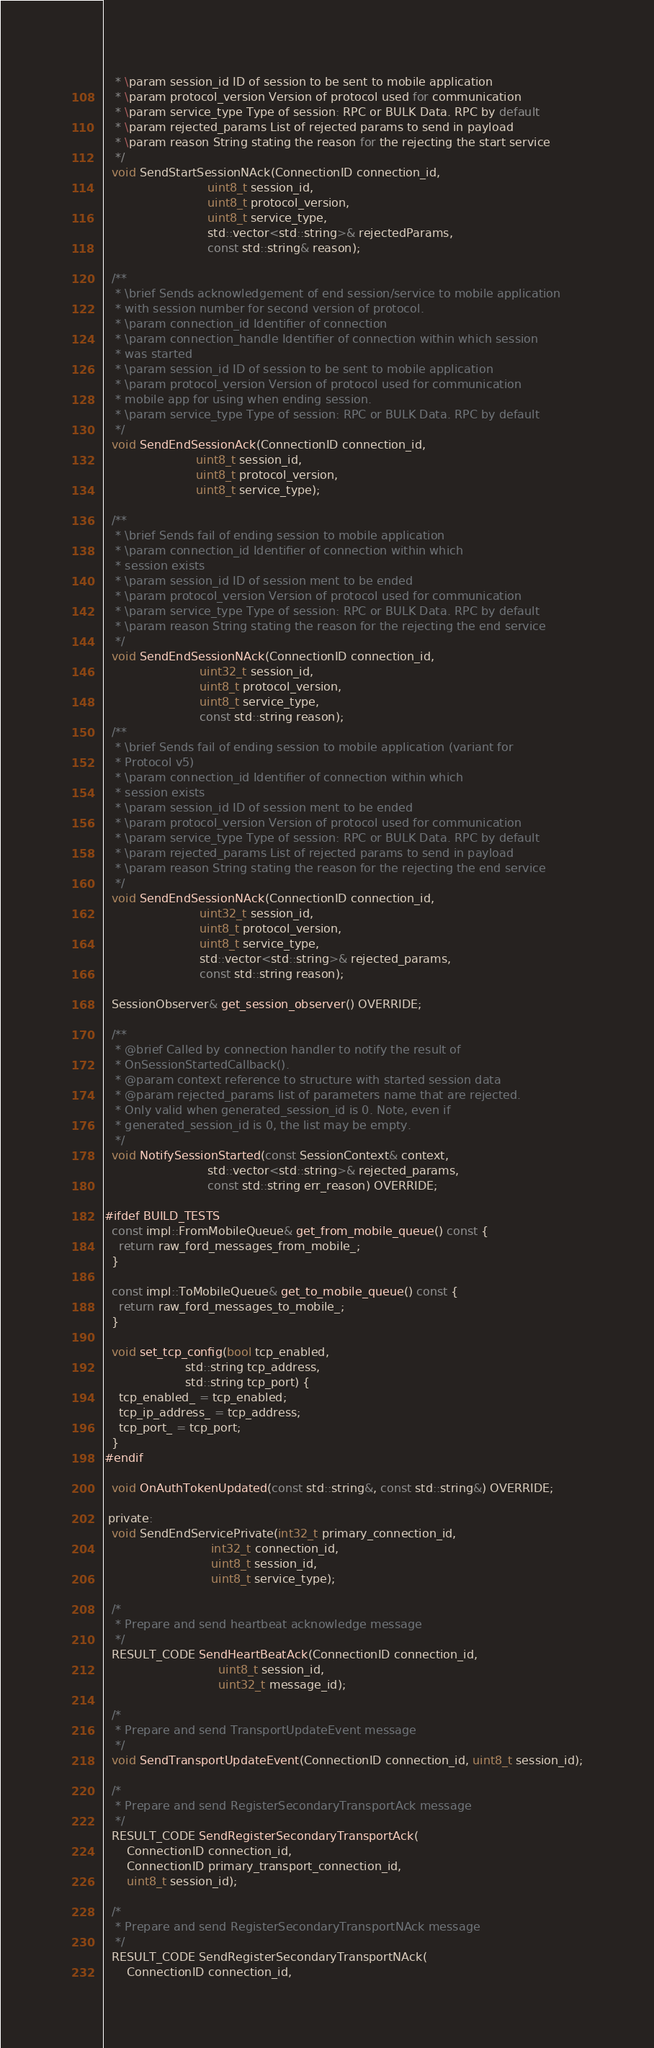<code> <loc_0><loc_0><loc_500><loc_500><_C_>   * \param session_id ID of session to be sent to mobile application
   * \param protocol_version Version of protocol used for communication
   * \param service_type Type of session: RPC or BULK Data. RPC by default
   * \param rejected_params List of rejected params to send in payload
   * \param reason String stating the reason for the rejecting the start service
   */
  void SendStartSessionNAck(ConnectionID connection_id,
                            uint8_t session_id,
                            uint8_t protocol_version,
                            uint8_t service_type,
                            std::vector<std::string>& rejectedParams,
                            const std::string& reason);

  /**
   * \brief Sends acknowledgement of end session/service to mobile application
   * with session number for second version of protocol.
   * \param connection_id Identifier of connection
   * \param connection_handle Identifier of connection within which session
   * was started
   * \param session_id ID of session to be sent to mobile application
   * \param protocol_version Version of protocol used for communication
   * mobile app for using when ending session.
   * \param service_type Type of session: RPC or BULK Data. RPC by default
   */
  void SendEndSessionAck(ConnectionID connection_id,
                         uint8_t session_id,
                         uint8_t protocol_version,
                         uint8_t service_type);

  /**
   * \brief Sends fail of ending session to mobile application
   * \param connection_id Identifier of connection within which
   * session exists
   * \param session_id ID of session ment to be ended
   * \param protocol_version Version of protocol used for communication
   * \param service_type Type of session: RPC or BULK Data. RPC by default
   * \param reason String stating the reason for the rejecting the end service
   */
  void SendEndSessionNAck(ConnectionID connection_id,
                          uint32_t session_id,
                          uint8_t protocol_version,
                          uint8_t service_type,
                          const std::string reason);
  /**
   * \brief Sends fail of ending session to mobile application (variant for
   * Protocol v5)
   * \param connection_id Identifier of connection within which
   * session exists
   * \param session_id ID of session ment to be ended
   * \param protocol_version Version of protocol used for communication
   * \param service_type Type of session: RPC or BULK Data. RPC by default
   * \param rejected_params List of rejected params to send in payload
   * \param reason String stating the reason for the rejecting the end service
   */
  void SendEndSessionNAck(ConnectionID connection_id,
                          uint32_t session_id,
                          uint8_t protocol_version,
                          uint8_t service_type,
                          std::vector<std::string>& rejected_params,
                          const std::string reason);

  SessionObserver& get_session_observer() OVERRIDE;

  /**
   * @brief Called by connection handler to notify the result of
   * OnSessionStartedCallback().
   * @param context reference to structure with started session data
   * @param rejected_params list of parameters name that are rejected.
   * Only valid when generated_session_id is 0. Note, even if
   * generated_session_id is 0, the list may be empty.
   */
  void NotifySessionStarted(const SessionContext& context,
                            std::vector<std::string>& rejected_params,
                            const std::string err_reason) OVERRIDE;

#ifdef BUILD_TESTS
  const impl::FromMobileQueue& get_from_mobile_queue() const {
    return raw_ford_messages_from_mobile_;
  }

  const impl::ToMobileQueue& get_to_mobile_queue() const {
    return raw_ford_messages_to_mobile_;
  }

  void set_tcp_config(bool tcp_enabled,
                      std::string tcp_address,
                      std::string tcp_port) {
    tcp_enabled_ = tcp_enabled;
    tcp_ip_address_ = tcp_address;
    tcp_port_ = tcp_port;
  }
#endif

  void OnAuthTokenUpdated(const std::string&, const std::string&) OVERRIDE;

 private:
  void SendEndServicePrivate(int32_t primary_connection_id,
                             int32_t connection_id,
                             uint8_t session_id,
                             uint8_t service_type);

  /*
   * Prepare and send heartbeat acknowledge message
   */
  RESULT_CODE SendHeartBeatAck(ConnectionID connection_id,
                               uint8_t session_id,
                               uint32_t message_id);

  /*
   * Prepare and send TransportUpdateEvent message
   */
  void SendTransportUpdateEvent(ConnectionID connection_id, uint8_t session_id);

  /*
   * Prepare and send RegisterSecondaryTransportAck message
   */
  RESULT_CODE SendRegisterSecondaryTransportAck(
      ConnectionID connection_id,
      ConnectionID primary_transport_connection_id,
      uint8_t session_id);

  /*
   * Prepare and send RegisterSecondaryTransportNAck message
   */
  RESULT_CODE SendRegisterSecondaryTransportNAck(
      ConnectionID connection_id,</code> 